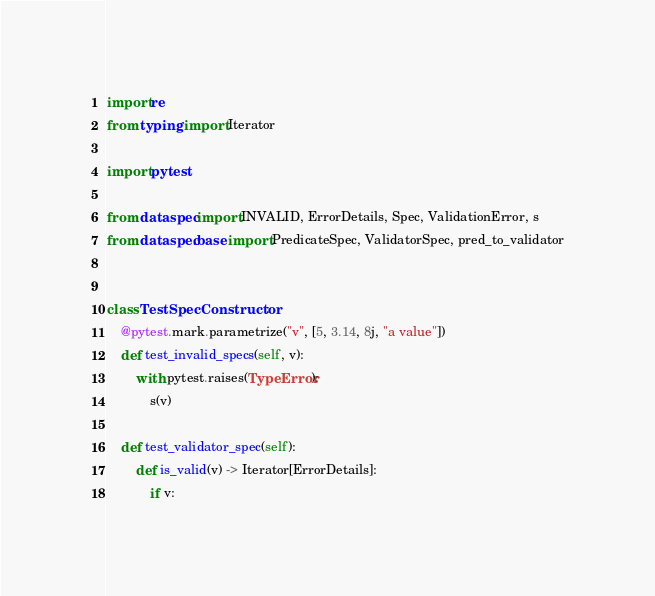Convert code to text. <code><loc_0><loc_0><loc_500><loc_500><_Python_>import re
from typing import Iterator

import pytest

from dataspec import INVALID, ErrorDetails, Spec, ValidationError, s
from dataspec.base import PredicateSpec, ValidatorSpec, pred_to_validator


class TestSpecConstructor:
    @pytest.mark.parametrize("v", [5, 3.14, 8j, "a value"])
    def test_invalid_specs(self, v):
        with pytest.raises(TypeError):
            s(v)

    def test_validator_spec(self):
        def is_valid(v) -> Iterator[ErrorDetails]:
            if v:</code> 